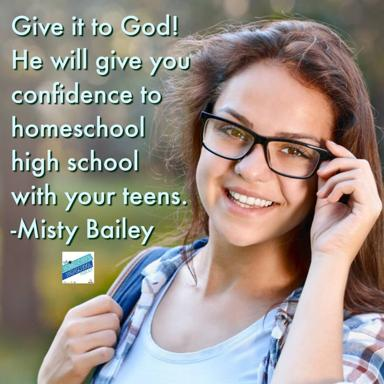Can you suggest some activities that might be beneficial for homeschooling teenagers? Absolutely, engaging teenagers in various educational activities such as science projects, debate clubs, and field trips can be incredibly beneficial. These activities not only enhance learning but also help in developing critical thinking skills and social interactions among peers. 